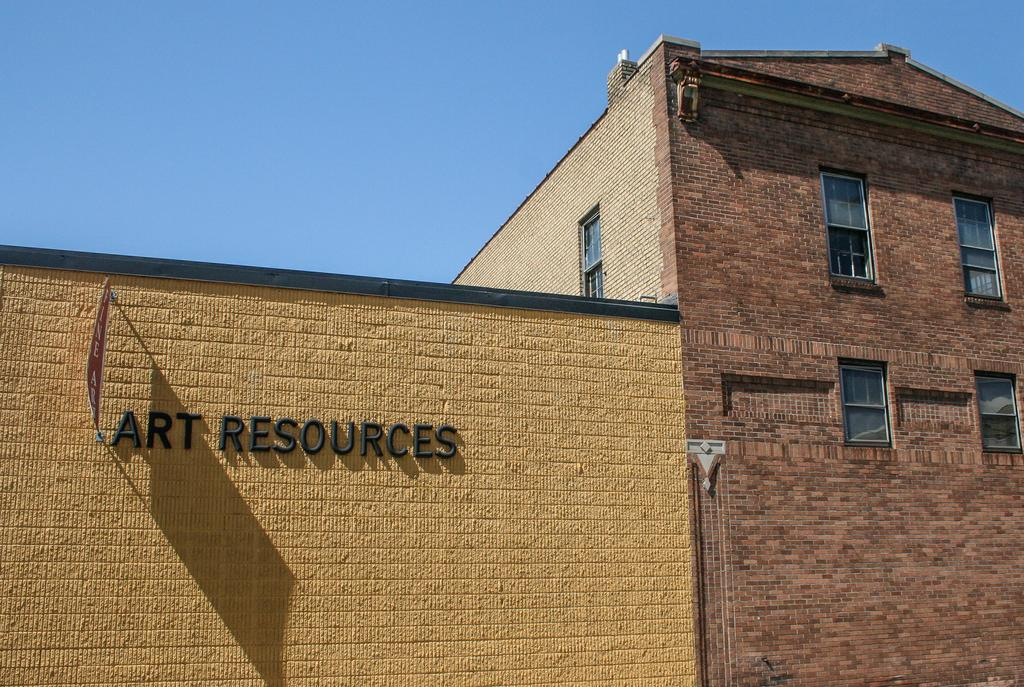What type of structures can be seen in the image? There are buildings in the image. What else is visible in the image besides the buildings? There is text visible in the image. What can be seen in the sky in the image? There are clouds in the sky. How many bats are hanging from the buildings in the image? There are no bats visible in the image; only buildings, text, and clouds are present. 